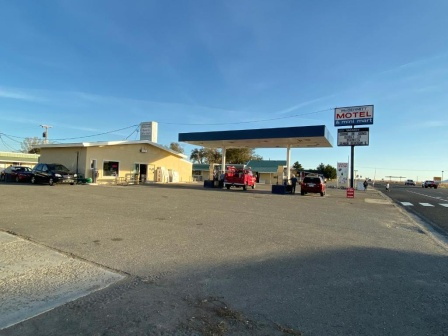Describe the structure and style of the motel sign. The motel sign is straightforward and functional, with a design typical of many roadside accommodations. The sign's background is white, providing a stark contrast to the bold red letters that spell out 'MOTEL'. This high-contrast color scheme ensures visibility from a distance, catching the eye of potential guests. Its rectangular shape and unadorned style emphasize utility over aesthetics, typical of signs meant to be read quickly by passing drivers. 